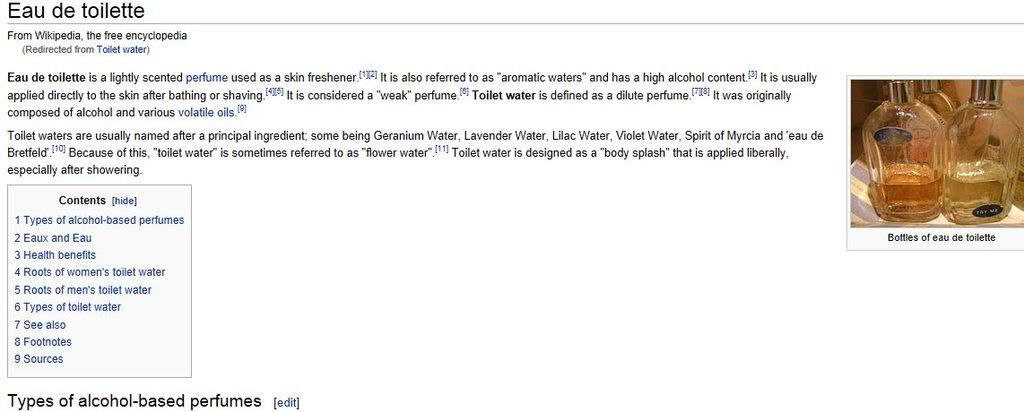<image>
Share a concise interpretation of the image provided. The wikipedia page for Eau de toilette perfume 